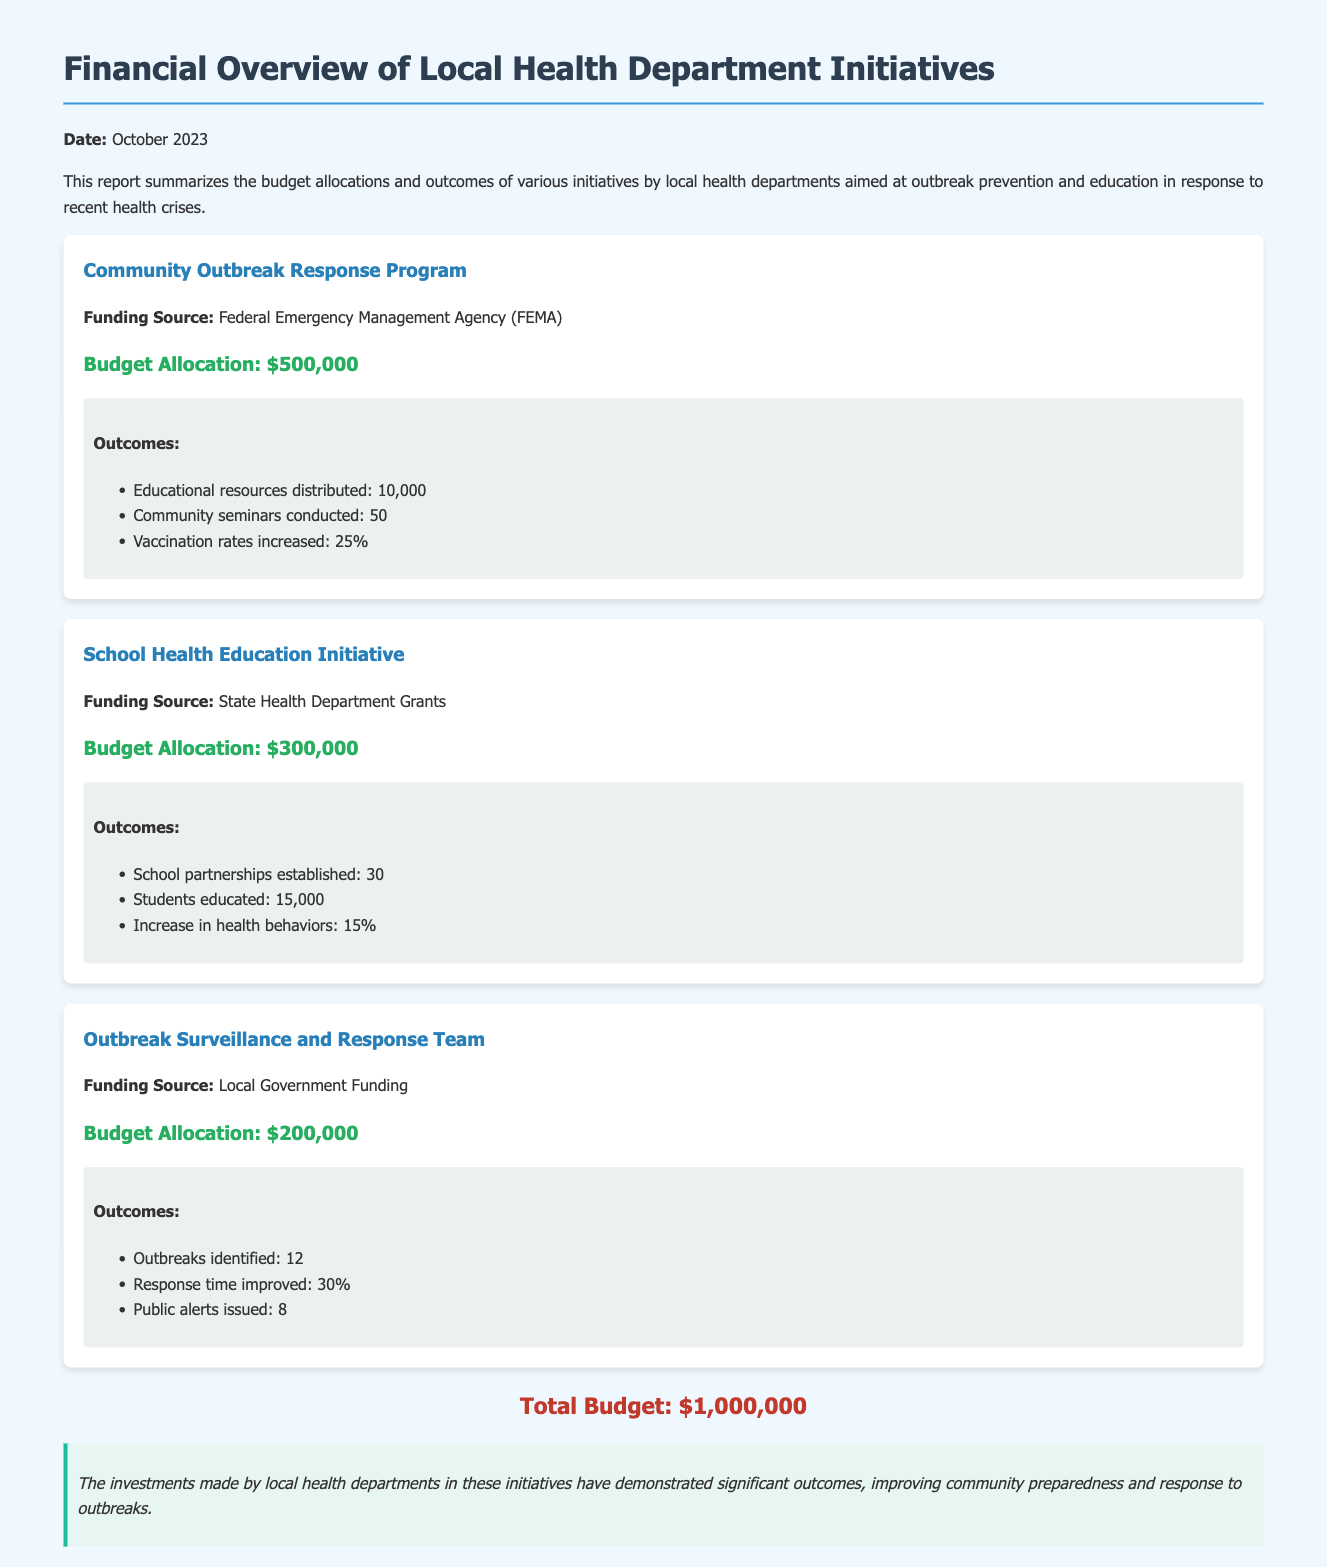What is the total budget? The total budget is provided at the end of the document and represents the overall funding for the initiatives, stated as $1,000,000.
Answer: $1,000,000 How many community seminars were conducted? The number of community seminars conducted is detailed under the outcomes for the Community Outbreak Response Program, which states 50 seminars were held.
Answer: 50 What was the budget allocation for the School Health Education Initiative? The specific budget allocation for the School Health Education Initiative is mentioned as $300,000.
Answer: $300,000 How many outbreaks did the Outbreak Surveillance and Response Team identify? The number of outbreaks identified is listed under the outcomes of the Outbreak Surveillance and Response Team, which is stated as 12.
Answer: 12 What percentage increase in vaccination rates was achieved? The percentage increase in vaccination rates is provided under the outcomes for the Community Outbreak Response Program, noted as 25%.
Answer: 25% Which funding source supported the Community Outbreak Response Program? The funding source for the Community Outbreak Response Program is explicitly stated as the Federal Emergency Management Agency (FEMA).
Answer: Federal Emergency Management Agency (FEMA) How many students were educated through the School Health Education Initiative? The document specifies that 15,000 students were educated through the School Health Education Initiative.
Answer: 15,000 What is the improvement percentage in response time reported by the Outbreak Surveillance and Response Team? The document indicates that the response time improved by 30%, which is an outcome for the Outbreak Surveillance and Response Team.
Answer: 30% How many public alerts were issued by the Outbreak Surveillance and Response Team? The total number of public alerts issued is mentioned as 8 in the outcomes for the Outbreak Surveillance and Response Team.
Answer: 8 